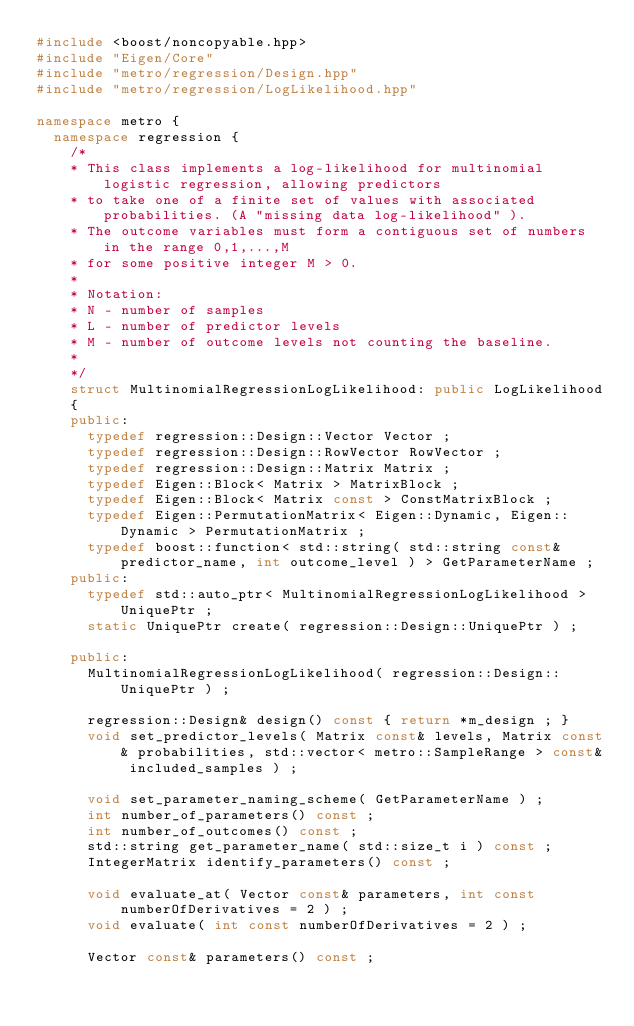<code> <loc_0><loc_0><loc_500><loc_500><_C++_>#include <boost/noncopyable.hpp>
#include "Eigen/Core"
#include "metro/regression/Design.hpp"
#include "metro/regression/LogLikelihood.hpp"

namespace metro {
	namespace regression {
		/*
		* This class implements a log-likelihood for multinomial logistic regression, allowing predictors
		* to take one of a finite set of values with associated probabilities. (A "missing data log-likelihood" ).
		* The outcome variables must form a contiguous set of numbers in the range 0,1,...,M
		* for some positive integer M > 0.
		*
		* Notation:
		* N - number of samples
		* L - number of predictor levels
		* M - number of outcome levels not counting the baseline.
		* 
		*/
		struct MultinomialRegressionLogLikelihood: public LogLikelihood
		{
		public:
			typedef regression::Design::Vector Vector ;
			typedef regression::Design::RowVector RowVector ;
			typedef regression::Design::Matrix Matrix ;
			typedef Eigen::Block< Matrix > MatrixBlock ;
			typedef Eigen::Block< Matrix const > ConstMatrixBlock ;
			typedef Eigen::PermutationMatrix< Eigen::Dynamic, Eigen::Dynamic > PermutationMatrix ;
			typedef boost::function< std::string( std::string const& predictor_name, int outcome_level ) > GetParameterName ;
		public:
			typedef std::auto_ptr< MultinomialRegressionLogLikelihood > UniquePtr ;
			static UniquePtr create( regression::Design::UniquePtr ) ;
			
		public:
			MultinomialRegressionLogLikelihood( regression::Design::UniquePtr ) ;

			regression::Design& design() const { return *m_design ; }
			void set_predictor_levels( Matrix const& levels, Matrix const& probabilities, std::vector< metro::SampleRange > const& included_samples ) ;
		
			void set_parameter_naming_scheme( GetParameterName ) ;
			int number_of_parameters() const ;
			int number_of_outcomes() const ;
			std::string get_parameter_name( std::size_t i ) const ;		
			IntegerMatrix identify_parameters() const ;
			
			void evaluate_at( Vector const& parameters, int const numberOfDerivatives = 2 ) ;
			void evaluate( int const numberOfDerivatives = 2 ) ;

			Vector const& parameters() const ;</code> 